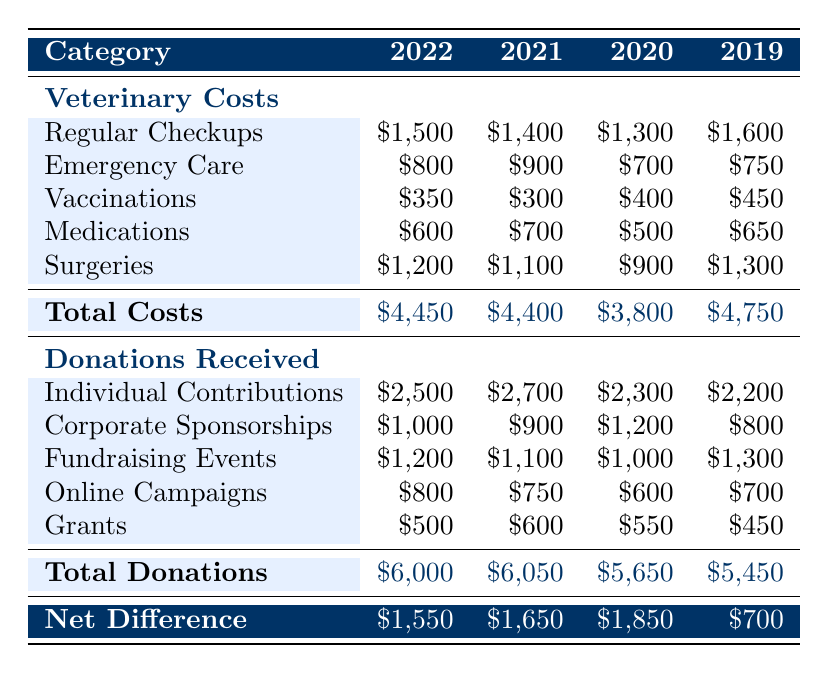What were the total veterinary costs in 2022? The total veterinary costs for 2022 are stated under the "Total Costs" row, which is \$4,450
Answer: 4,450 What is the amount received from individual contributions in 2021? The amount received from individual contributions in 2021 is found in the donations section for that year, which is \$2,700
Answer: 2,700 What is the average total cost of veterinary care over the years 2019 to 2022? To find the average total cost, sum the total costs from 2019 to 2022: 4750 + 4400 + 4450 + 4450 = 18,250. Divide by the number of years (4): 18,250 / 4 = 4,562.5
Answer: 4,562.5 Did veterinary costs increase from 2020 to 2021? Comparing the total costs for 2020 and 2021, \$4,400 (2021) is greater than \$3,800 (2020), so the answer is yes
Answer: Yes What were the total donations received in 2020? The total donations received in 2020 are under the "Total Donations" row for that year, which is \$5,650
Answer: 5,650 Which year had the highest individual contributions and what was the amount? The data shows that 2021 had the highest individual contributions with an amount of \$2,700, which is the maximum value in that row
Answer: 2021, 2,700 What is the difference in total donations between 2021 and 2022? The total donations for 2021 is \$6,050 and for 2022 is \$6,000. The difference is calculated as \$6,050 - \$6,000 = \$50
Answer: 50 Was the total cost of veterinary care in 2019 higher than that in 2020? The total cost in 2019 was \$4,750 and in 2020 it was \$3,800. Since \$4,750 is greater than \$3,800, the answer is yes
Answer: Yes What was the total cost for emergency care for all years combined? To find the total cost for emergency care, sum the emergency care costs for all years: 750 (2019) + 700 (2020) + 900 (2021) + 800 (2022) = 3,150
Answer: 3,150 